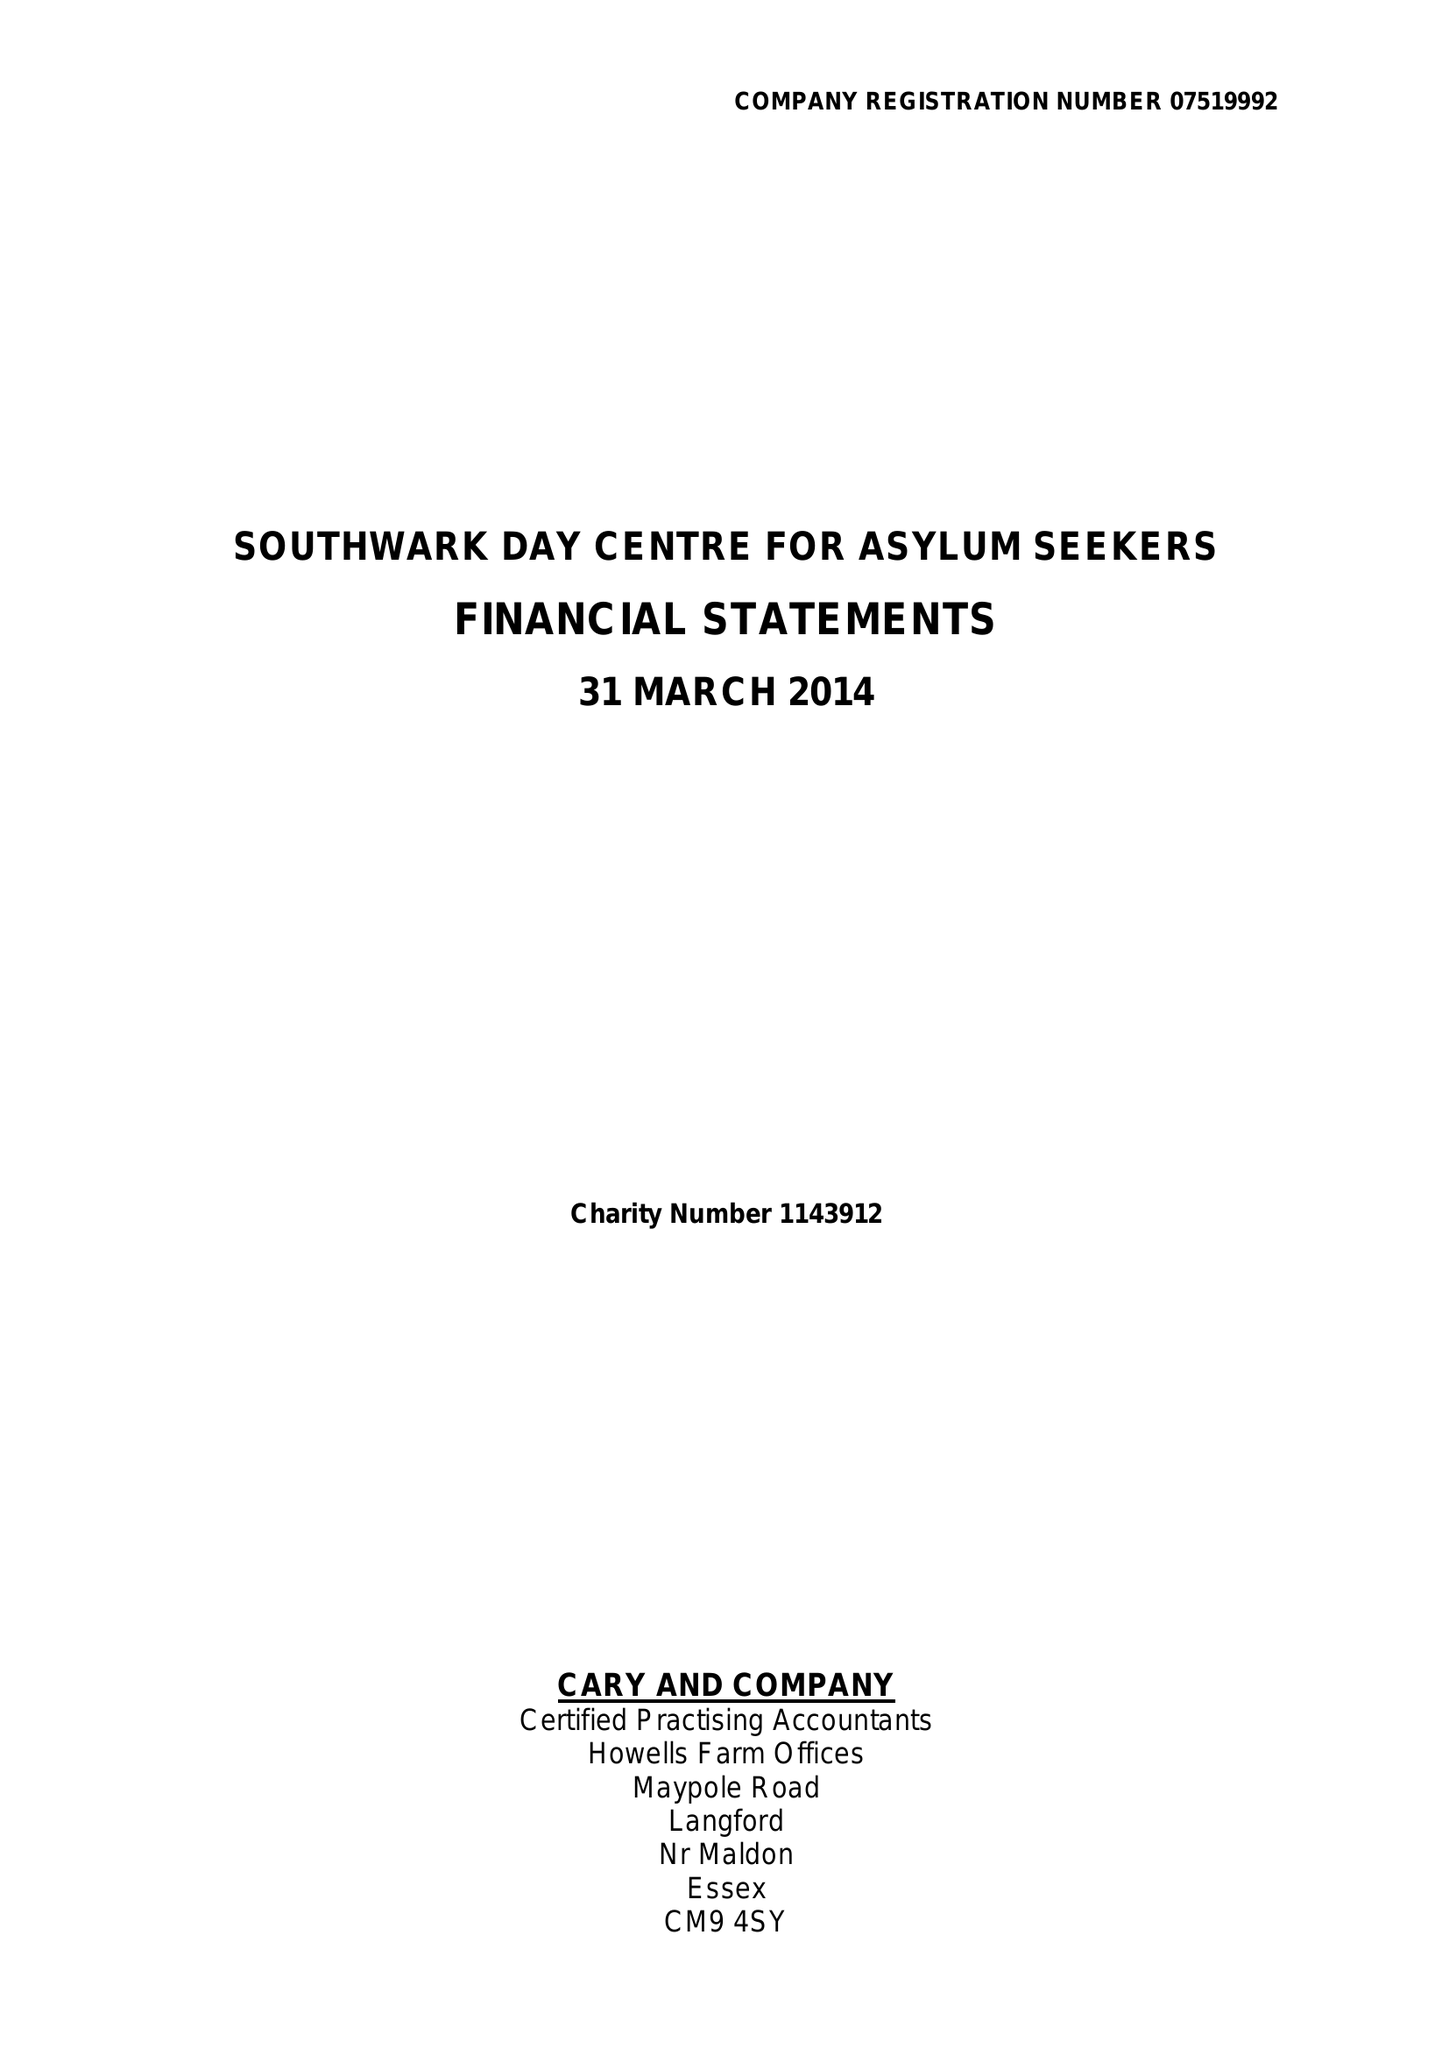What is the value for the address__postcode?
Answer the question using a single word or phrase. SE15 4AN 